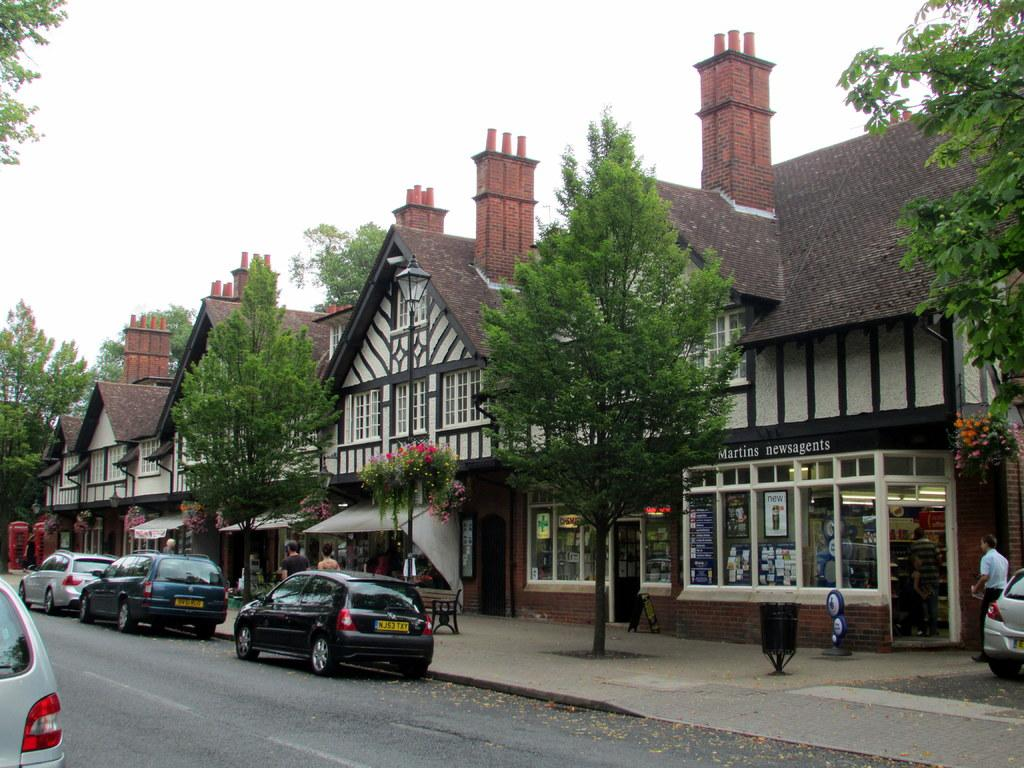What type of structures can be seen in the image? There are buildings in the image. What other natural elements are present in the image? There are trees in the image. What can be seen on the road in the image? Cars are parked on the road in the image. Can you describe the person in the image? There is a person standing on the footpath in the image. What is visible at the top of the image? The sky is clear and visible at the top of the image. Where are the snails crawling on the buildings in the image? There are no snails present in the image. What type of sand can be seen on the person's shoes in the image? There is no sand or reference to shoes in the image. 